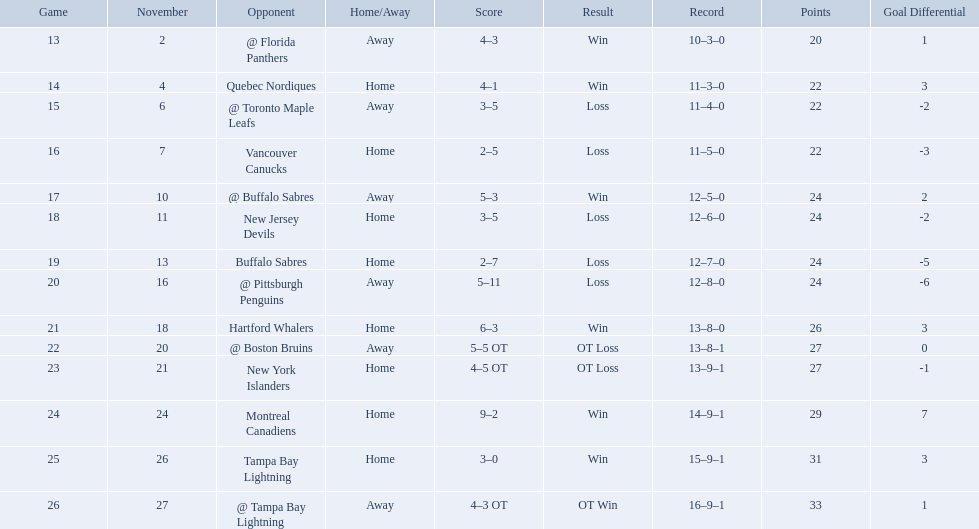Who did the philadelphia flyers play in game 17? @ Buffalo Sabres. Could you parse the entire table as a dict? {'header': ['Game', 'November', 'Opponent', 'Home/Away', 'Score', 'Result', 'Record', 'Points', 'Goal Differential'], 'rows': [['13', '2', '@ Florida Panthers', 'Away', '4–3', 'Win', '10–3–0', '20', '1'], ['14', '4', 'Quebec Nordiques', 'Home', '4–1', 'Win', '11–3–0', '22', '3'], ['15', '6', '@ Toronto Maple Leafs', 'Away', '3–5', 'Loss', '11–4–0', '22', '-2'], ['16', '7', 'Vancouver Canucks', 'Home', '2–5', 'Loss', '11–5–0', '22', '-3'], ['17', '10', '@ Buffalo Sabres', 'Away', '5–3', 'Win', '12–5–0', '24', '2'], ['18', '11', 'New Jersey Devils', 'Home', '3–5', 'Loss', '12–6–0', '24', '-2'], ['19', '13', 'Buffalo Sabres', 'Home', '2–7', 'Loss', '12–7–0', '24', '-5'], ['20', '16', '@ Pittsburgh Penguins', 'Away', '5–11', 'Loss', '12–8–0', '24', '-6'], ['21', '18', 'Hartford Whalers', 'Home', '6–3', 'Win', '13–8–0', '26', '3'], ['22', '20', '@ Boston Bruins', 'Away', '5–5 OT', 'OT Loss', '13–8–1', '27', '0'], ['23', '21', 'New York Islanders', 'Home', '4–5 OT', 'OT Loss', '13–9–1', '27', '-1'], ['24', '24', 'Montreal Canadiens', 'Home', '9–2', 'Win', '14–9–1', '29', '7'], ['25', '26', 'Tampa Bay Lightning', 'Home', '3–0', 'Win', '15–9–1', '31', '3'], ['26', '27', '@ Tampa Bay Lightning', 'Away', '4–3 OT', 'OT Win', '16–9–1', '33', '1']]} What was the score of the november 10th game against the buffalo sabres? 5–3. Which team in the atlantic division had less points than the philadelphia flyers? Tampa Bay Lightning. Which teams scored 35 points or more in total? Hartford Whalers, @ Boston Bruins, New York Islanders, Montreal Canadiens, Tampa Bay Lightning, @ Tampa Bay Lightning. Of those teams, which team was the only one to score 3-0? Tampa Bay Lightning. Who are all of the teams? @ Florida Panthers, Quebec Nordiques, @ Toronto Maple Leafs, Vancouver Canucks, @ Buffalo Sabres, New Jersey Devils, Buffalo Sabres, @ Pittsburgh Penguins, Hartford Whalers, @ Boston Bruins, New York Islanders, Montreal Canadiens, Tampa Bay Lightning. What games finished in overtime? 22, 23, 26. In game number 23, who did they face? New York Islanders. 